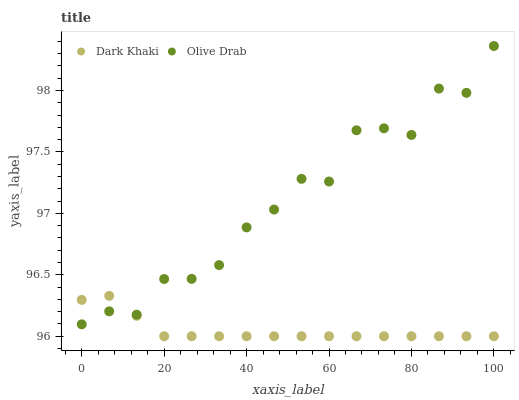Does Dark Khaki have the minimum area under the curve?
Answer yes or no. Yes. Does Olive Drab have the maximum area under the curve?
Answer yes or no. Yes. Does Olive Drab have the minimum area under the curve?
Answer yes or no. No. Is Dark Khaki the smoothest?
Answer yes or no. Yes. Is Olive Drab the roughest?
Answer yes or no. Yes. Is Olive Drab the smoothest?
Answer yes or no. No. Does Dark Khaki have the lowest value?
Answer yes or no. Yes. Does Olive Drab have the lowest value?
Answer yes or no. No. Does Olive Drab have the highest value?
Answer yes or no. Yes. Does Dark Khaki intersect Olive Drab?
Answer yes or no. Yes. Is Dark Khaki less than Olive Drab?
Answer yes or no. No. Is Dark Khaki greater than Olive Drab?
Answer yes or no. No. 